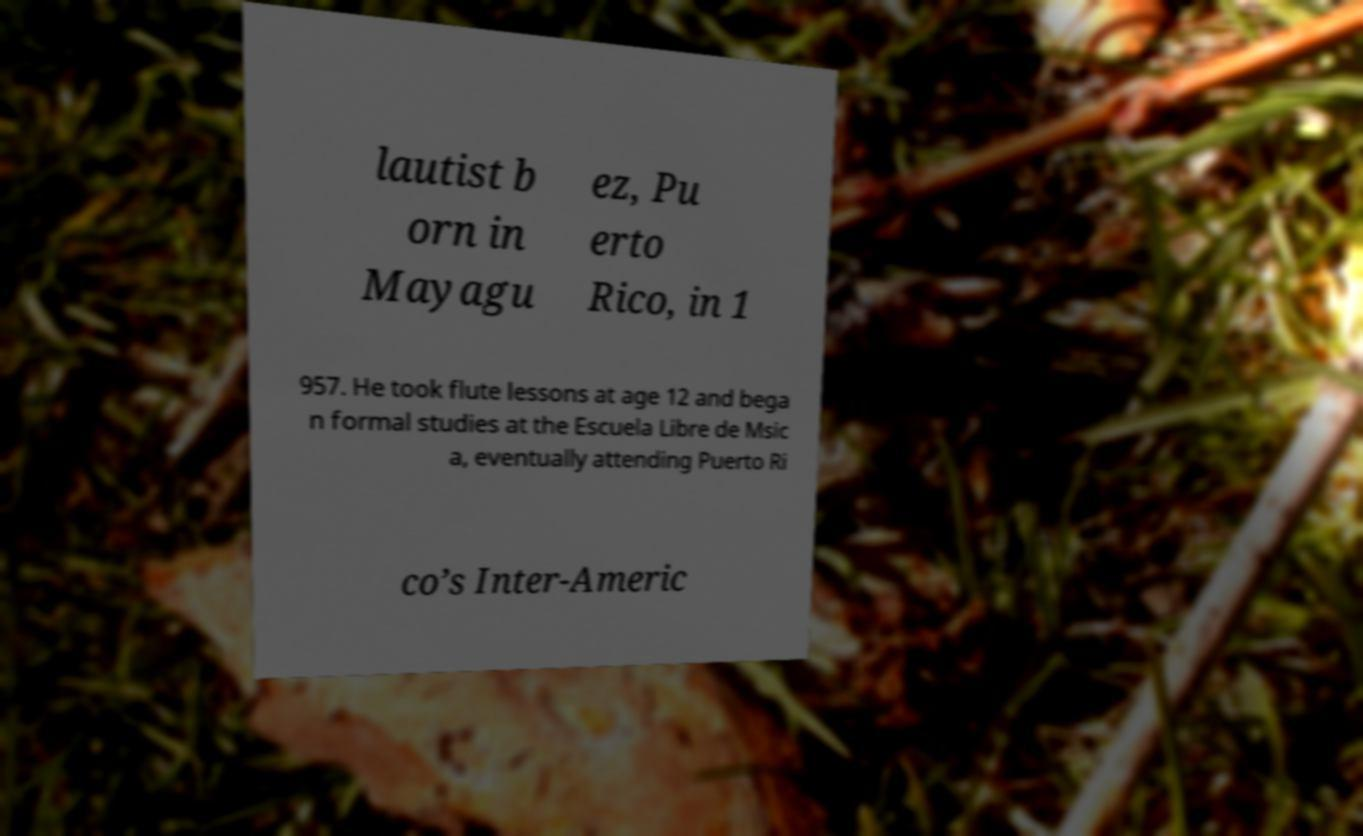Could you extract and type out the text from this image? lautist b orn in Mayagu ez, Pu erto Rico, in 1 957. He took flute lessons at age 12 and bega n formal studies at the Escuela Libre de Msic a, eventually attending Puerto Ri co’s Inter-Americ 